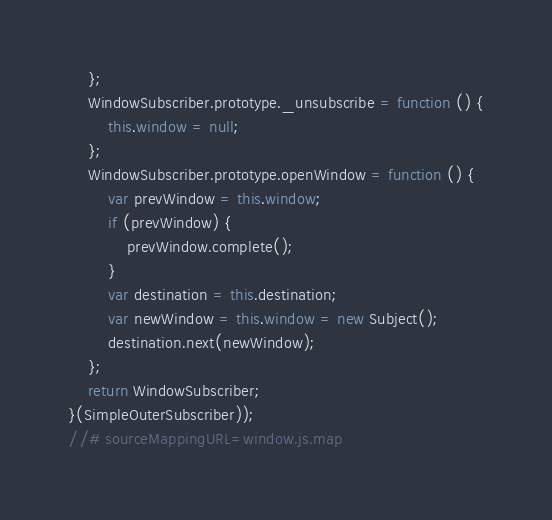Convert code to text. <code><loc_0><loc_0><loc_500><loc_500><_JavaScript_>    };
    WindowSubscriber.prototype._unsubscribe = function () {
        this.window = null;
    };
    WindowSubscriber.prototype.openWindow = function () {
        var prevWindow = this.window;
        if (prevWindow) {
            prevWindow.complete();
        }
        var destination = this.destination;
        var newWindow = this.window = new Subject();
        destination.next(newWindow);
    };
    return WindowSubscriber;
}(SimpleOuterSubscriber));
//# sourceMappingURL=window.js.map
</code> 